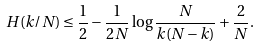<formula> <loc_0><loc_0><loc_500><loc_500>H ( k / N ) \leq \frac { 1 } { 2 } - \frac { 1 } { 2 N } \log \frac { N } { k ( N - k ) } + \frac { 2 } { N } .</formula> 